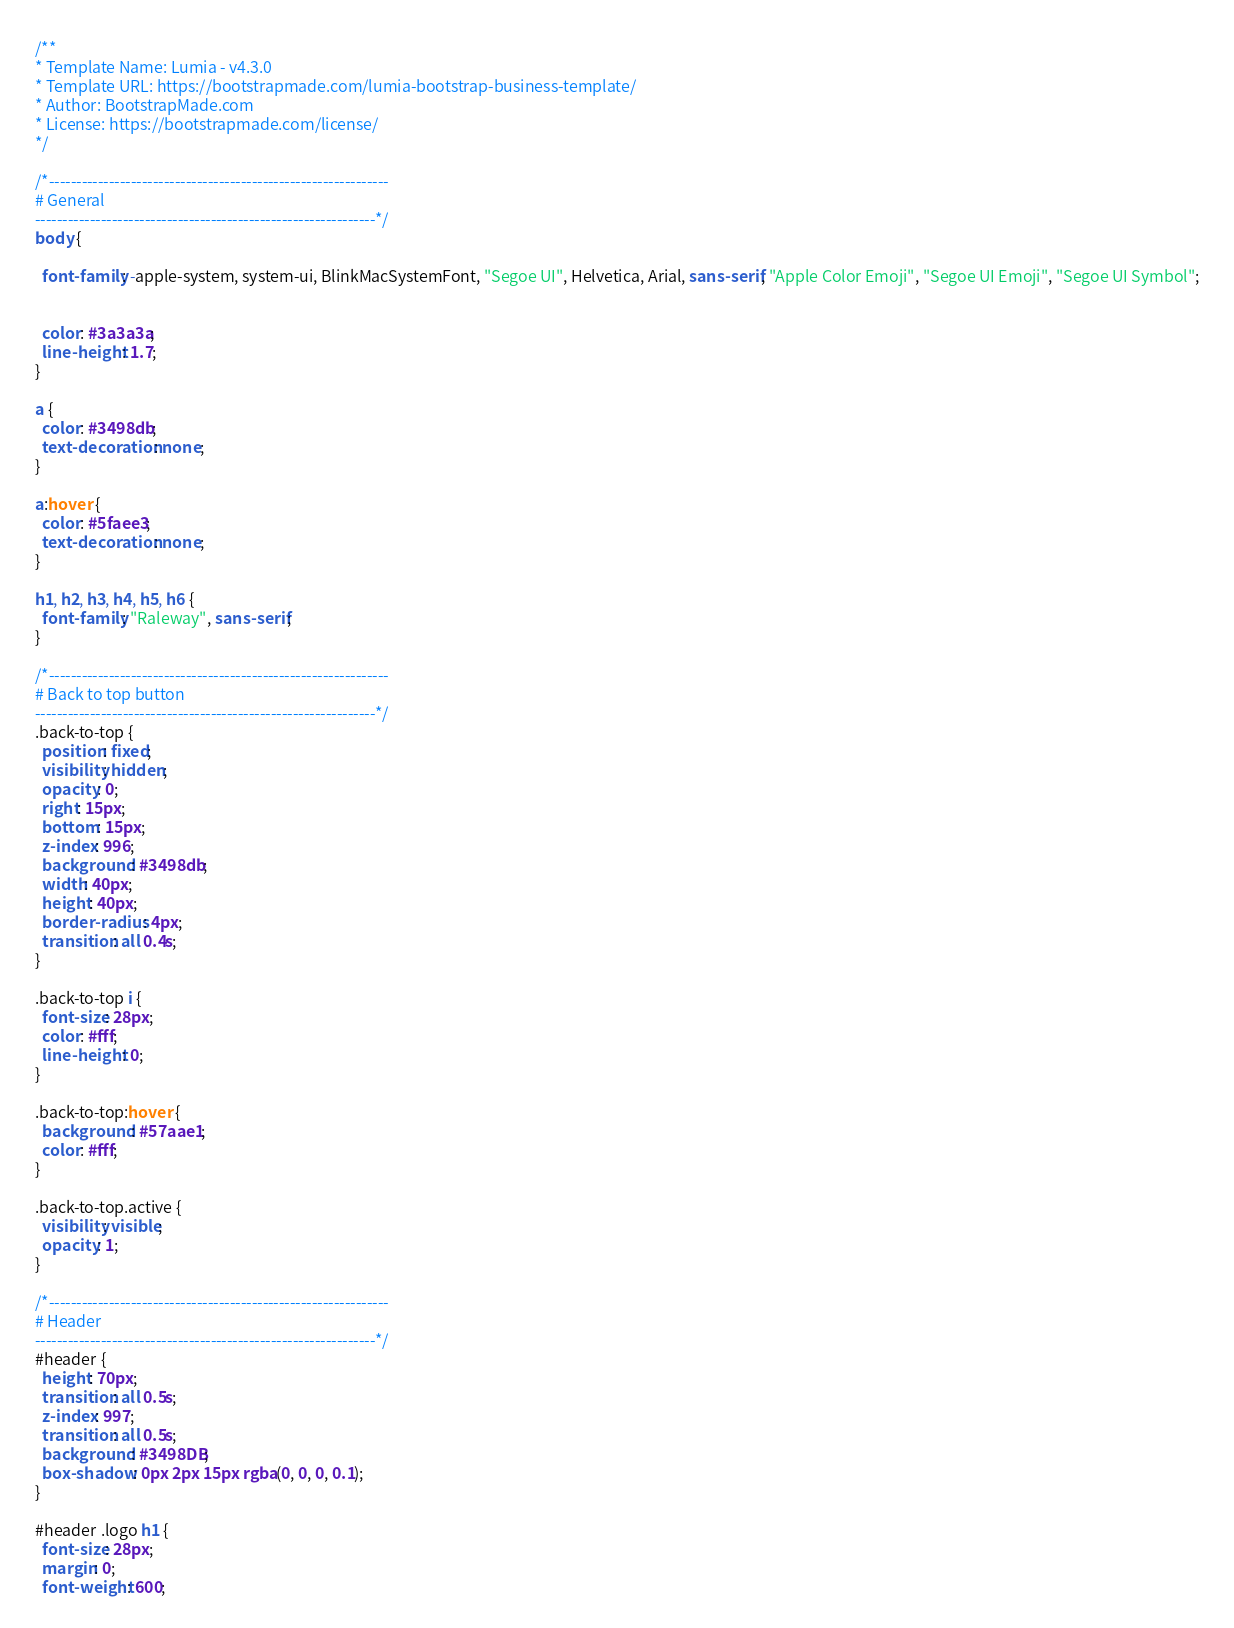<code> <loc_0><loc_0><loc_500><loc_500><_CSS_>/**
* Template Name: Lumia - v4.3.0
* Template URL: https://bootstrapmade.com/lumia-bootstrap-business-template/
* Author: BootstrapMade.com
* License: https://bootstrapmade.com/license/
*/

/*--------------------------------------------------------------
# General
--------------------------------------------------------------*/
body {
  
  font-family: -apple-system, system-ui, BlinkMacSystemFont, "Segoe UI", Helvetica, Arial, sans-serif, "Apple Color Emoji", "Segoe UI Emoji", "Segoe UI Symbol";


  color: #3a3a3a;
  line-height: 1.7;
}

a {
  color: #3498db;
  text-decoration: none;
}

a:hover {
  color: #5faee3;
  text-decoration: none;
}

h1, h2, h3, h4, h5, h6 {
  font-family: "Raleway", sans-serif;
}

/*--------------------------------------------------------------
# Back to top button
--------------------------------------------------------------*/
.back-to-top {
  position: fixed;
  visibility: hidden;
  opacity: 0;
  right: 15px;
  bottom: 15px;
  z-index: 996;
  background: #3498db;
  width: 40px;
  height: 40px;
  border-radius: 4px;
  transition: all 0.4s;
}

.back-to-top i {
  font-size: 28px;
  color: #fff;
  line-height: 0;
}

.back-to-top:hover {
  background: #57aae1;
  color: #fff;
}

.back-to-top.active {
  visibility: visible;
  opacity: 1;
}

/*--------------------------------------------------------------
# Header
--------------------------------------------------------------*/
#header {
  height: 70px;
  transition: all 0.5s;
  z-index: 997;
  transition: all 0.5s;
  background: #3498DB;
  box-shadow: 0px 2px 15px rgba(0, 0, 0, 0.1);
}

#header .logo h1 {
  font-size: 28px;
  margin: 0;
  font-weight: 600;</code> 